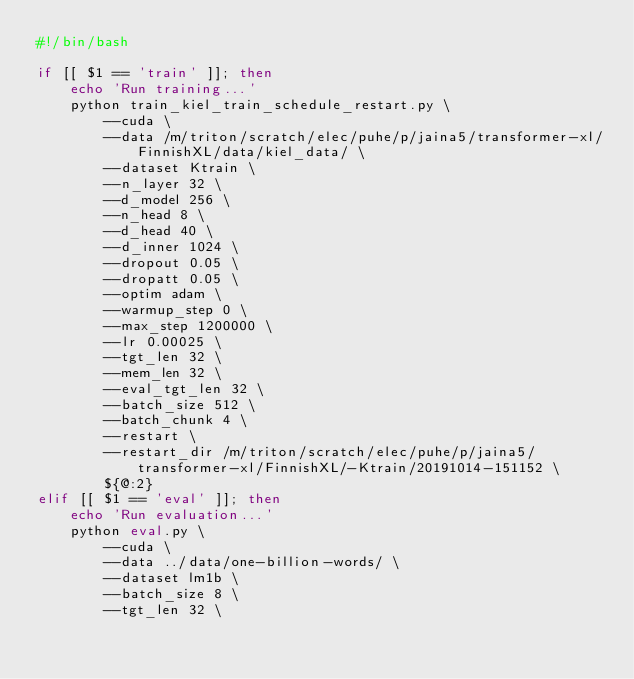<code> <loc_0><loc_0><loc_500><loc_500><_Bash_>#!/bin/bash

if [[ $1 == 'train' ]]; then
    echo 'Run training...'
    python train_kiel_train_schedule_restart.py \
        --cuda \
        --data /m/triton/scratch/elec/puhe/p/jaina5/transformer-xl/FinnishXL/data/kiel_data/ \
        --dataset Ktrain \
        --n_layer 32 \
        --d_model 256 \
        --n_head 8 \
        --d_head 40 \
        --d_inner 1024 \
        --dropout 0.05 \
        --dropatt 0.05 \
        --optim adam \
        --warmup_step 0 \
        --max_step 1200000 \
        --lr 0.00025 \
        --tgt_len 32 \
        --mem_len 32 \
        --eval_tgt_len 32 \
        --batch_size 512 \
        --batch_chunk 4 \
        --restart \
        --restart_dir /m/triton/scratch/elec/puhe/p/jaina5/transformer-xl/FinnishXL/-Ktrain/20191014-151152 \
        ${@:2}
elif [[ $1 == 'eval' ]]; then
    echo 'Run evaluation...'
    python eval.py \
        --cuda \
        --data ../data/one-billion-words/ \
        --dataset lm1b \
        --batch_size 8 \
        --tgt_len 32 \</code> 